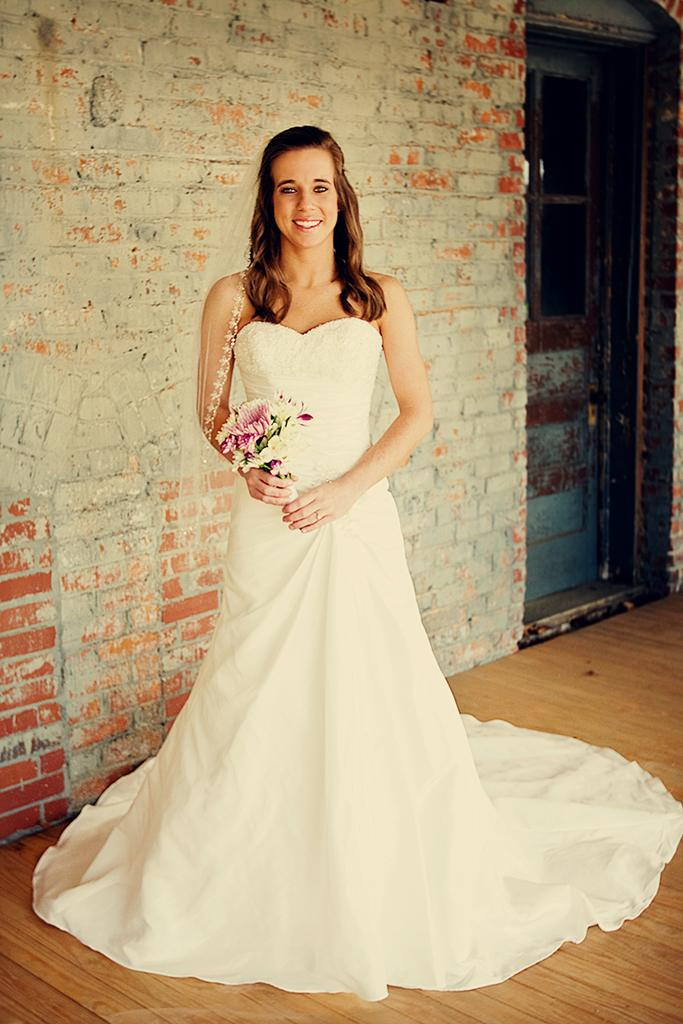Who is present in the image? There is a woman in the image. What is the woman doing in the image? The woman is standing in the image. What is the woman's facial expression in the image? The woman is smiling in the image. What type of structure is visible in the image? There is a brick wall and another wall in the image. What type of veil is the woman wearing in the image? There is no veil present in the image; the woman is not wearing any head covering. 